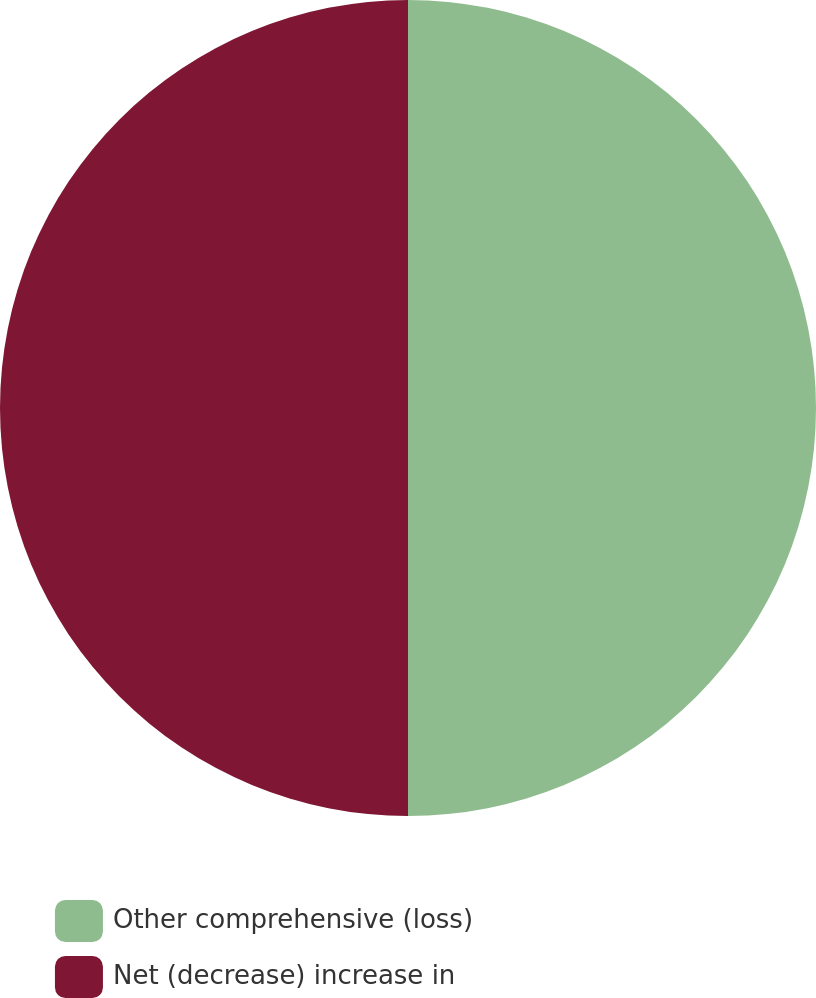<chart> <loc_0><loc_0><loc_500><loc_500><pie_chart><fcel>Other comprehensive (loss)<fcel>Net (decrease) increase in<nl><fcel>50.0%<fcel>50.0%<nl></chart> 